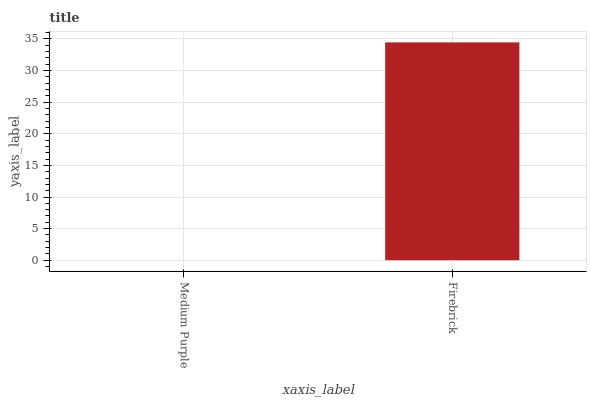Is Medium Purple the minimum?
Answer yes or no. Yes. Is Firebrick the maximum?
Answer yes or no. Yes. Is Firebrick the minimum?
Answer yes or no. No. Is Firebrick greater than Medium Purple?
Answer yes or no. Yes. Is Medium Purple less than Firebrick?
Answer yes or no. Yes. Is Medium Purple greater than Firebrick?
Answer yes or no. No. Is Firebrick less than Medium Purple?
Answer yes or no. No. Is Firebrick the high median?
Answer yes or no. Yes. Is Medium Purple the low median?
Answer yes or no. Yes. Is Medium Purple the high median?
Answer yes or no. No. Is Firebrick the low median?
Answer yes or no. No. 